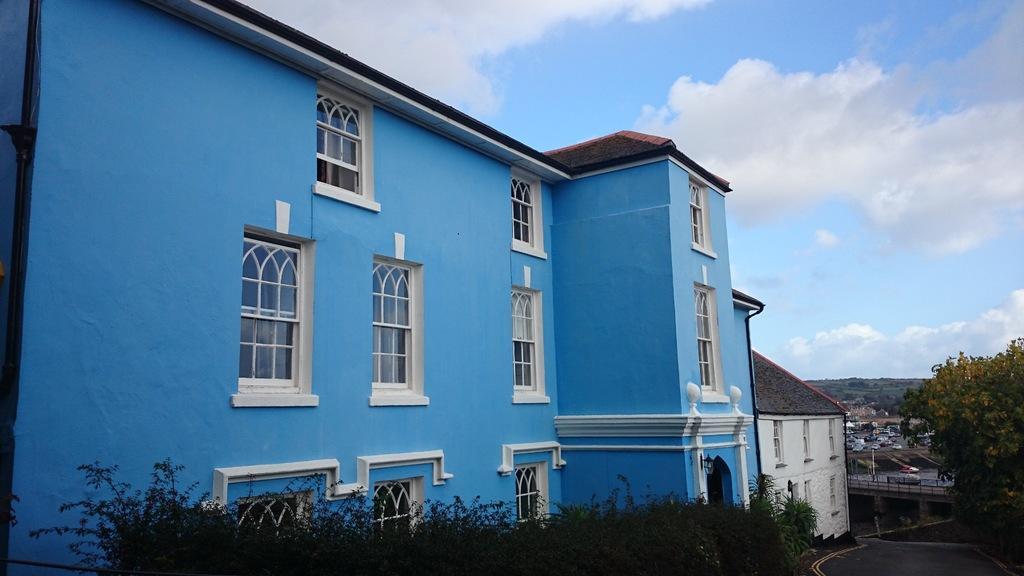Please provide a concise description of this image. On the left side of this image I can see two buildings along with the windows. At the bottom of the image there are some plants. On the right side there is a road. Beside the road I can see the trees. In the background there are many vehicles. At the top of the image I can see the sky and clouds. 